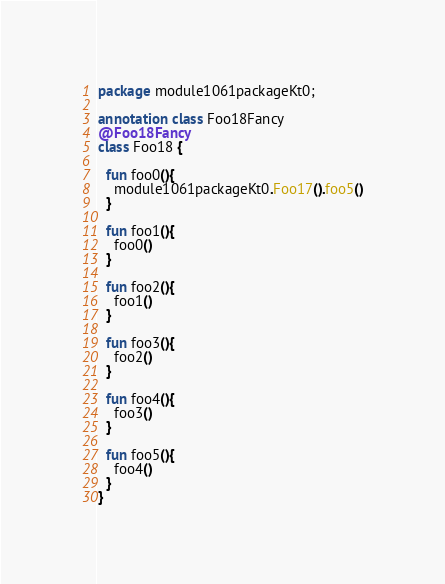Convert code to text. <code><loc_0><loc_0><loc_500><loc_500><_Kotlin_>package module1061packageKt0;

annotation class Foo18Fancy
@Foo18Fancy
class Foo18 {

  fun foo0(){
    module1061packageKt0.Foo17().foo5()
  }

  fun foo1(){
    foo0()
  }

  fun foo2(){
    foo1()
  }

  fun foo3(){
    foo2()
  }

  fun foo4(){
    foo3()
  }

  fun foo5(){
    foo4()
  }
}</code> 